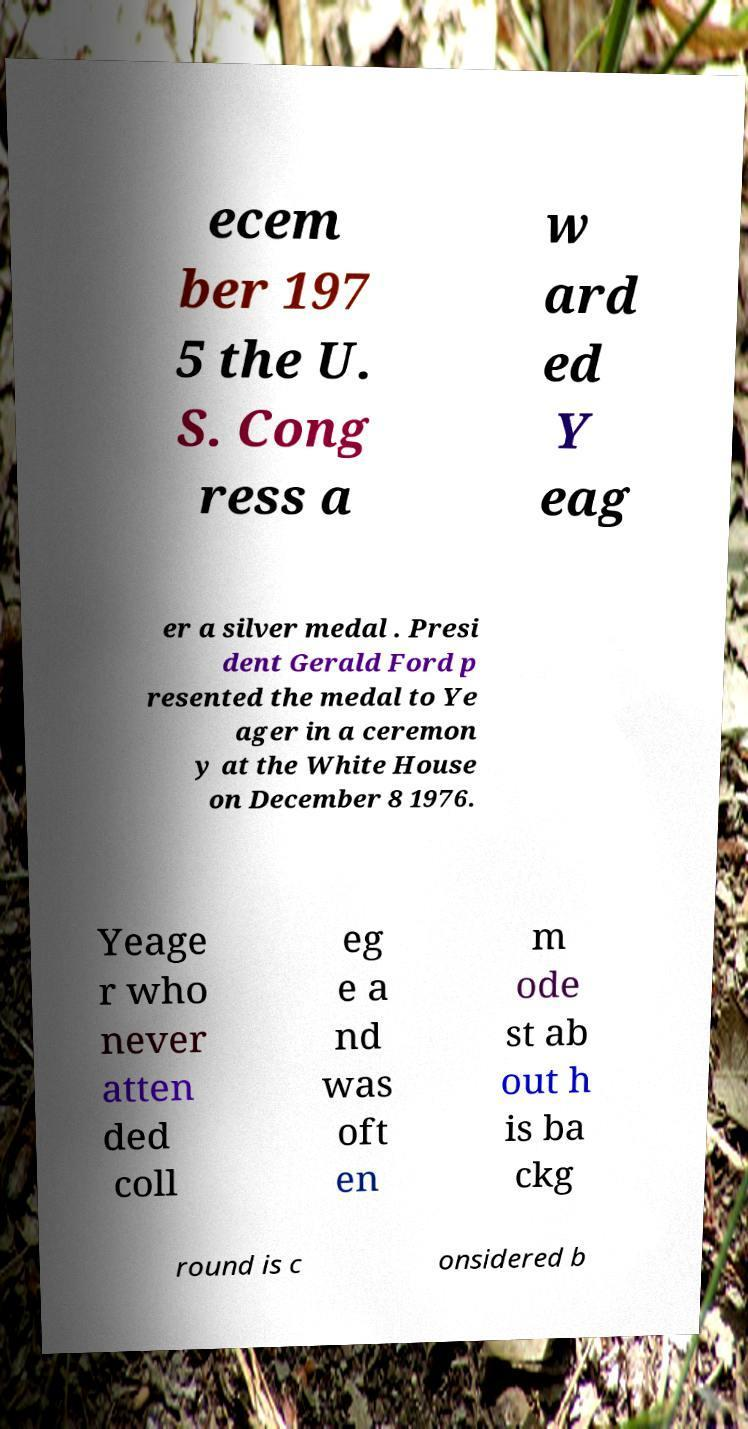Could you extract and type out the text from this image? ecem ber 197 5 the U. S. Cong ress a w ard ed Y eag er a silver medal . Presi dent Gerald Ford p resented the medal to Ye ager in a ceremon y at the White House on December 8 1976. Yeage r who never atten ded coll eg e a nd was oft en m ode st ab out h is ba ckg round is c onsidered b 